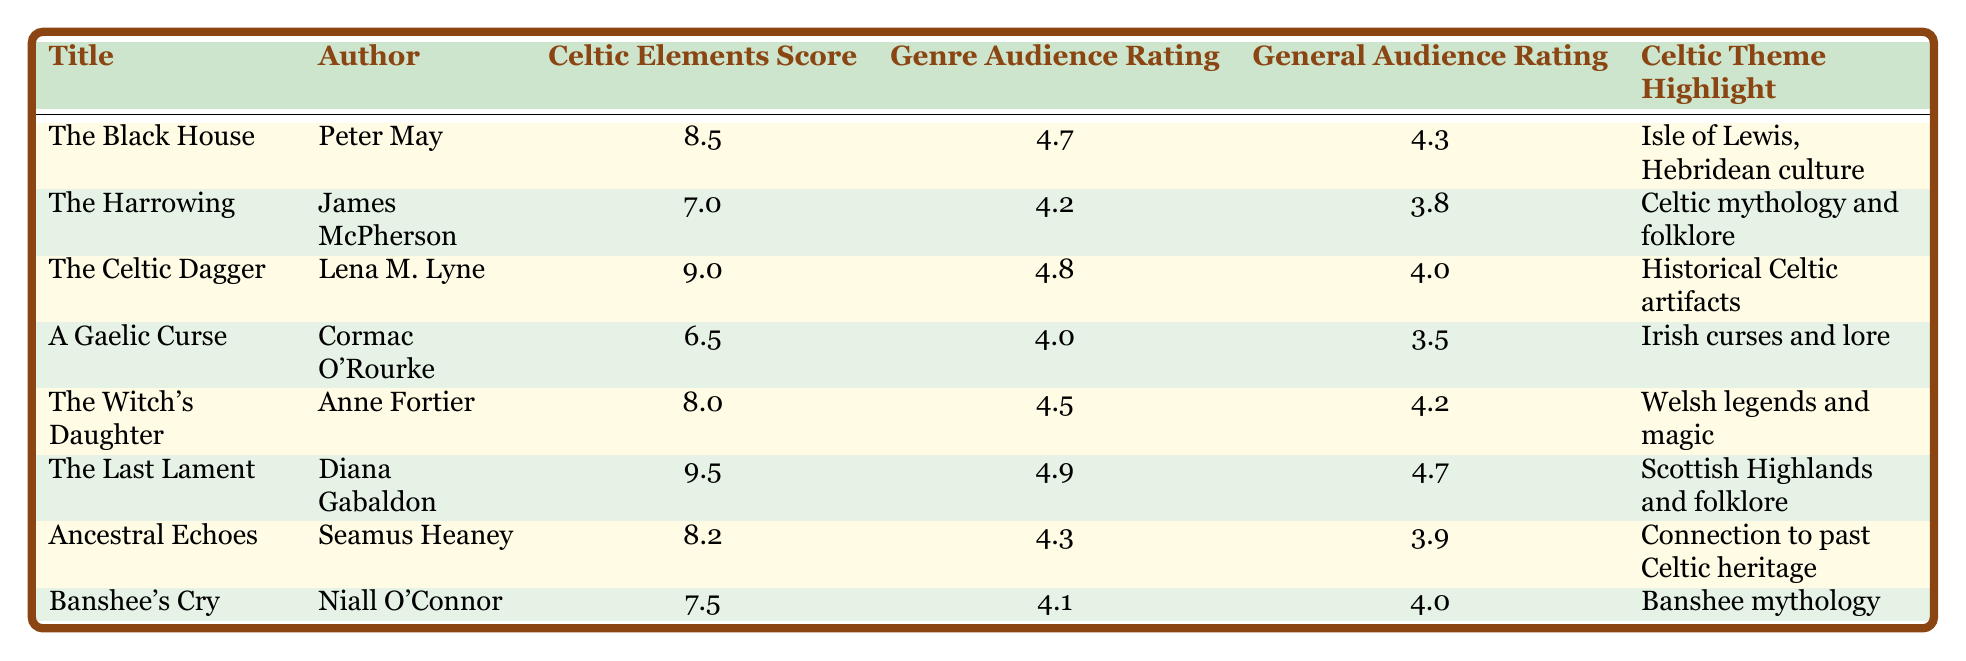What is the title of the book with the highest Celtic Elements Score? The table indicates that "The Last Lament" has the highest Celtic Elements Score of 9.5.
Answer: The Last Lament Which author wrote "The Witch's Daughter"? Directly referencing the table, "The Witch's Daughter" is attributed to Anne Fortier.
Answer: Anne Fortier What is the average Genre Audience Rating for the books listed? Calculating the average: (4.7 + 4.2 + 4.8 + 4.0 + 4.5 + 4.9 + 4.3 + 4.1) = 34.5, and there are 8 books, so the average is 34.5/8 = 4.3125, rounded to 4.31.
Answer: 4.31 Is there a book that received a General Audience Rating of 4.7 or higher? Checking the General Audience Ratings, "The Last Lament" and "The Black House" both have ratings of 4.7 and 4.3 respectively, so yes, at least one book meets this criterion.
Answer: Yes What is the difference between the highest and lowest Genre Audience Ratings? The highest Genre Audience Rating is from "The Last Lament" at 4.9, and the lowest is "A Gaelic Curse" at 4.0. The difference is 4.9 - 4.0 = 0.9.
Answer: 0.9 How many books have a Celtic Elements Score greater than 8? By reviewing the table, the books "The Celtic Dagger" (9.0), "The Last Lament" (9.5), and "The Black House" (8.5) have scores greater than 8. Therefore, there are 3 such books.
Answer: 3 Did "The Harrowing" receive a better General Audience Rating than "A Gaelic Curse"? Comparing the ratings, "The Harrowing" has a General Audience Rating of 3.8, while "A Gaelic Curse" stands at 3.5. Since 3.8 is greater than 3.5, the answer is yes.
Answer: Yes Which book has the lowest Celtic Elements Score? The table shows that "A Gaelic Curse" has the lowest Celtic Elements Score of 6.5 among the listed books.
Answer: A Gaelic Curse 